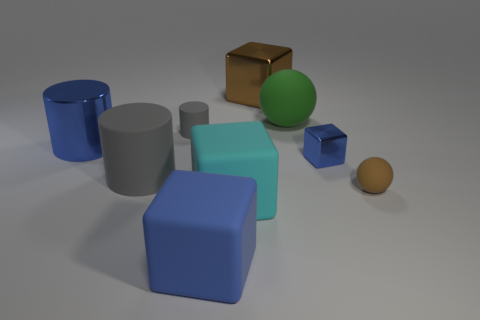Subtract all brown blocks. How many blocks are left? 3 Subtract all yellow cylinders. How many blue cubes are left? 2 Add 1 brown cubes. How many objects exist? 10 Subtract all brown blocks. How many blocks are left? 3 Subtract all balls. How many objects are left? 7 Subtract 3 cubes. How many cubes are left? 1 Subtract all large green things. Subtract all gray cylinders. How many objects are left? 6 Add 7 large blue objects. How many large blue objects are left? 9 Add 9 brown spheres. How many brown spheres exist? 10 Subtract 2 gray cylinders. How many objects are left? 7 